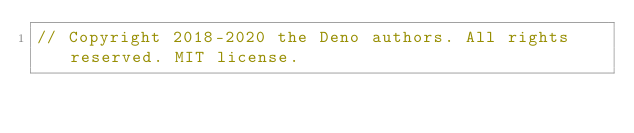<code> <loc_0><loc_0><loc_500><loc_500><_Rust_>// Copyright 2018-2020 the Deno authors. All rights reserved. MIT license.</code> 